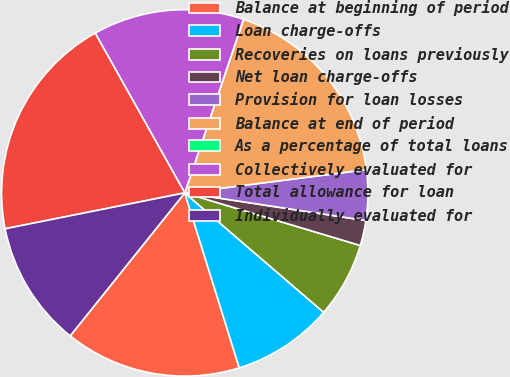Convert chart to OTSL. <chart><loc_0><loc_0><loc_500><loc_500><pie_chart><fcel>Balance at beginning of period<fcel>Loan charge-offs<fcel>Recoveries on loans previously<fcel>Net loan charge-offs<fcel>Provision for loan losses<fcel>Balance at end of period<fcel>As a percentage of total loans<fcel>Collectively evaluated for<fcel>Total allowance for loan<fcel>Individually evaluated for<nl><fcel>15.56%<fcel>8.89%<fcel>6.67%<fcel>2.22%<fcel>4.44%<fcel>17.78%<fcel>0.0%<fcel>13.33%<fcel>20.0%<fcel>11.11%<nl></chart> 